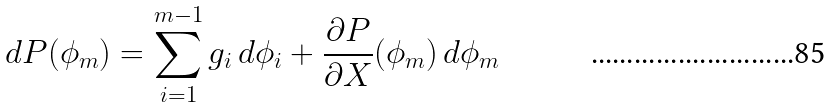Convert formula to latex. <formula><loc_0><loc_0><loc_500><loc_500>d P ( \phi _ { m } ) = \sum _ { i = 1 } ^ { m - 1 } g _ { i } \, d \phi _ { i } + \frac { \partial P } { \partial X } ( \phi _ { m } ) \, d \phi _ { m }</formula> 